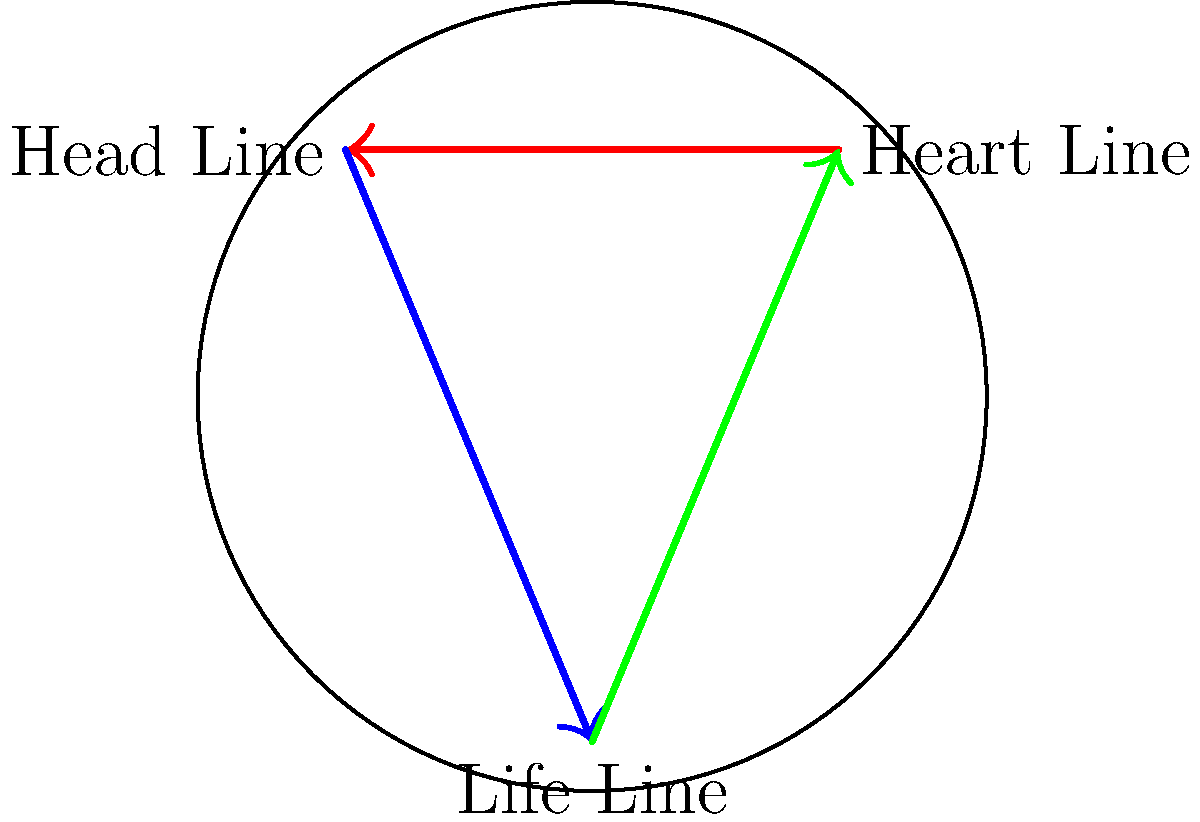In this stylized palm diagram, the heart, head, and life lines form a triangle. If the angle between the heart and head lines ($\alpha$) is 120°, and the angle between the head and life lines ($\beta$) is 100°, what is the angle between the life and heart lines ($\gamma$)? Let's approach this step-by-step:

1) In any triangle, the sum of all interior angles is always 180°. This is a fundamental property of triangles.

2) Let's denote the angles as follows:
   $\alpha$ (between heart and head lines) = 120°
   $\beta$ (between head and life lines) = 100°
   $\gamma$ (between life and heart lines) = unknown

3) We can set up an equation based on the fact that the sum of angles in a triangle is 180°:

   $\alpha + \beta + \gamma = 180°$

4) Substituting the known values:

   $120° + 100° + \gamma = 180°$

5) Simplifying:

   $220° + \gamma = 180°$

6) Subtracting 220° from both sides:

   $\gamma = 180° - 220° = -40°$

7) However, angles in a triangle cannot be negative. This means that $\gamma$ is actually the reflex angle, and we need to find its supplement to get the interior angle of the triangle.

8) The supplement of -40° is:

   $\gamma = 360° - |-40°| = 360° - 40° = 320°$

9) Therefore, the interior angle $\gamma$ is:

   $\gamma = 180° - 140° = 40°$
Answer: 40° 